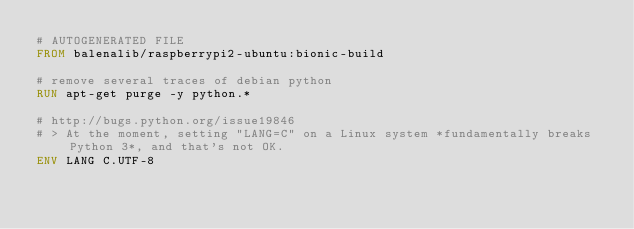<code> <loc_0><loc_0><loc_500><loc_500><_Dockerfile_># AUTOGENERATED FILE
FROM balenalib/raspberrypi2-ubuntu:bionic-build

# remove several traces of debian python
RUN apt-get purge -y python.*

# http://bugs.python.org/issue19846
# > At the moment, setting "LANG=C" on a Linux system *fundamentally breaks Python 3*, and that's not OK.
ENV LANG C.UTF-8
</code> 